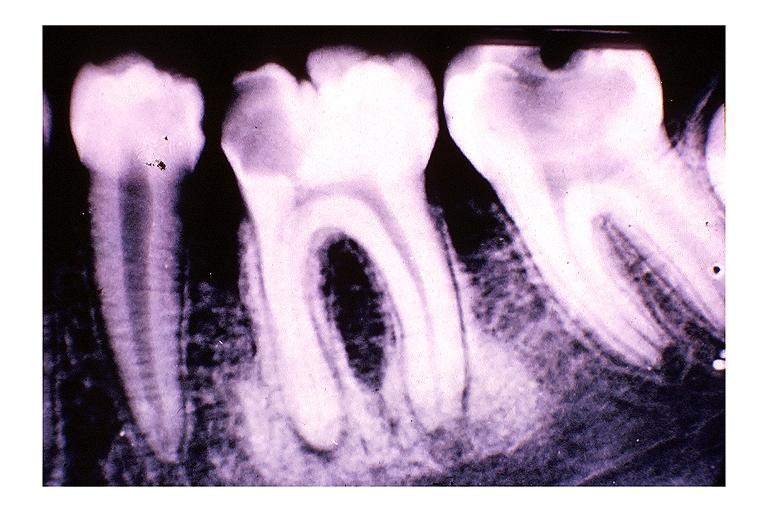where is this?
Answer the question using a single word or phrase. Oral 